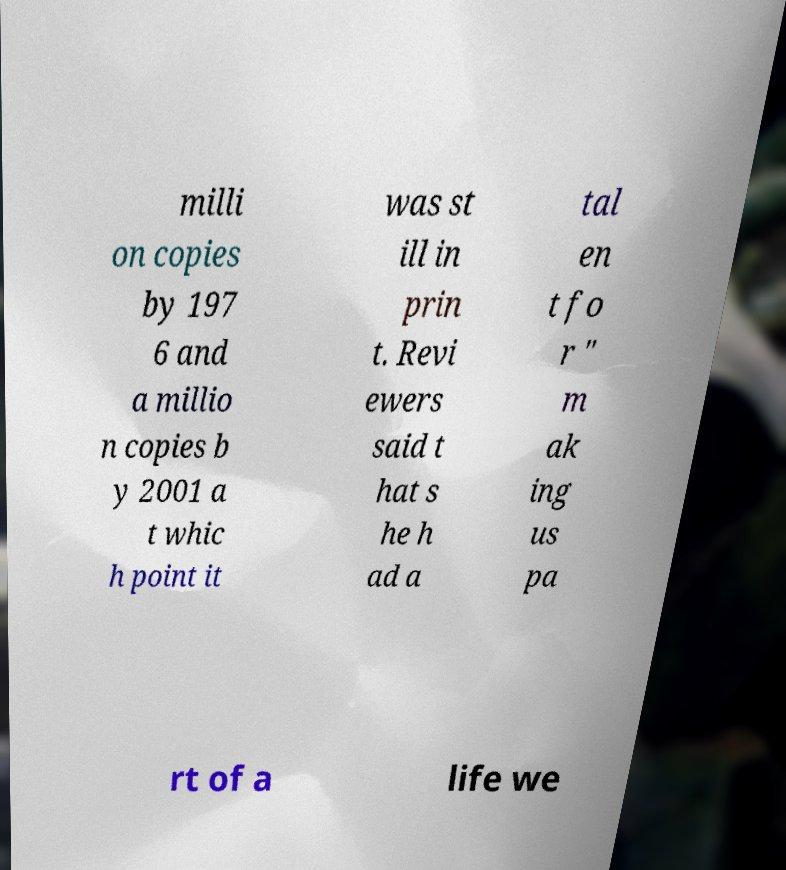Can you accurately transcribe the text from the provided image for me? milli on copies by 197 6 and a millio n copies b y 2001 a t whic h point it was st ill in prin t. Revi ewers said t hat s he h ad a tal en t fo r " m ak ing us pa rt of a life we 